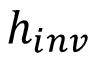<formula> <loc_0><loc_0><loc_500><loc_500>h _ { i n v }</formula> 